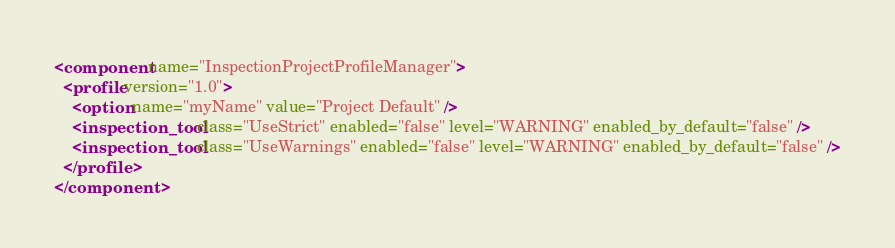Convert code to text. <code><loc_0><loc_0><loc_500><loc_500><_XML_><component name="InspectionProjectProfileManager">
  <profile version="1.0">
    <option name="myName" value="Project Default" />
    <inspection_tool class="UseStrict" enabled="false" level="WARNING" enabled_by_default="false" />
    <inspection_tool class="UseWarnings" enabled="false" level="WARNING" enabled_by_default="false" />
  </profile>
</component></code> 